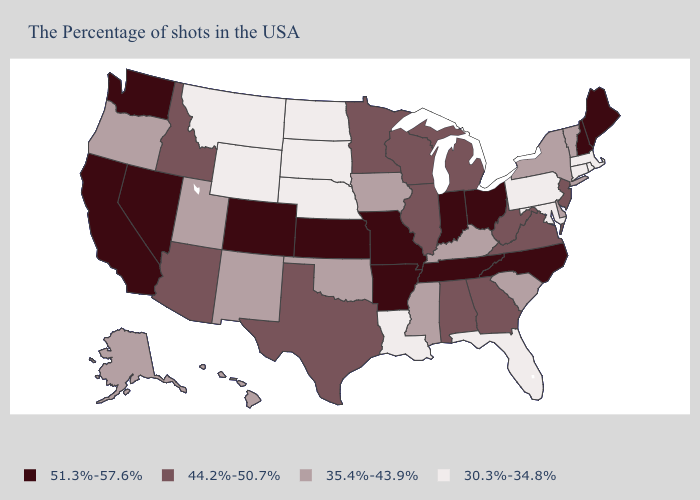Which states have the lowest value in the MidWest?
Concise answer only. Nebraska, South Dakota, North Dakota. What is the highest value in states that border Tennessee?
Keep it brief. 51.3%-57.6%. What is the value of Wisconsin?
Quick response, please. 44.2%-50.7%. What is the value of California?
Be succinct. 51.3%-57.6%. What is the highest value in the USA?
Give a very brief answer. 51.3%-57.6%. Among the states that border New Jersey , which have the lowest value?
Quick response, please. Pennsylvania. Does Montana have the lowest value in the USA?
Write a very short answer. Yes. Among the states that border North Carolina , does Tennessee have the highest value?
Give a very brief answer. Yes. Does Hawaii have a higher value than New Hampshire?
Keep it brief. No. Does North Carolina have the highest value in the USA?
Write a very short answer. Yes. Does Utah have a higher value than North Dakota?
Answer briefly. Yes. How many symbols are there in the legend?
Quick response, please. 4. Which states have the highest value in the USA?
Keep it brief. Maine, New Hampshire, North Carolina, Ohio, Indiana, Tennessee, Missouri, Arkansas, Kansas, Colorado, Nevada, California, Washington. Does South Carolina have the lowest value in the USA?
Keep it brief. No. Name the states that have a value in the range 51.3%-57.6%?
Keep it brief. Maine, New Hampshire, North Carolina, Ohio, Indiana, Tennessee, Missouri, Arkansas, Kansas, Colorado, Nevada, California, Washington. 